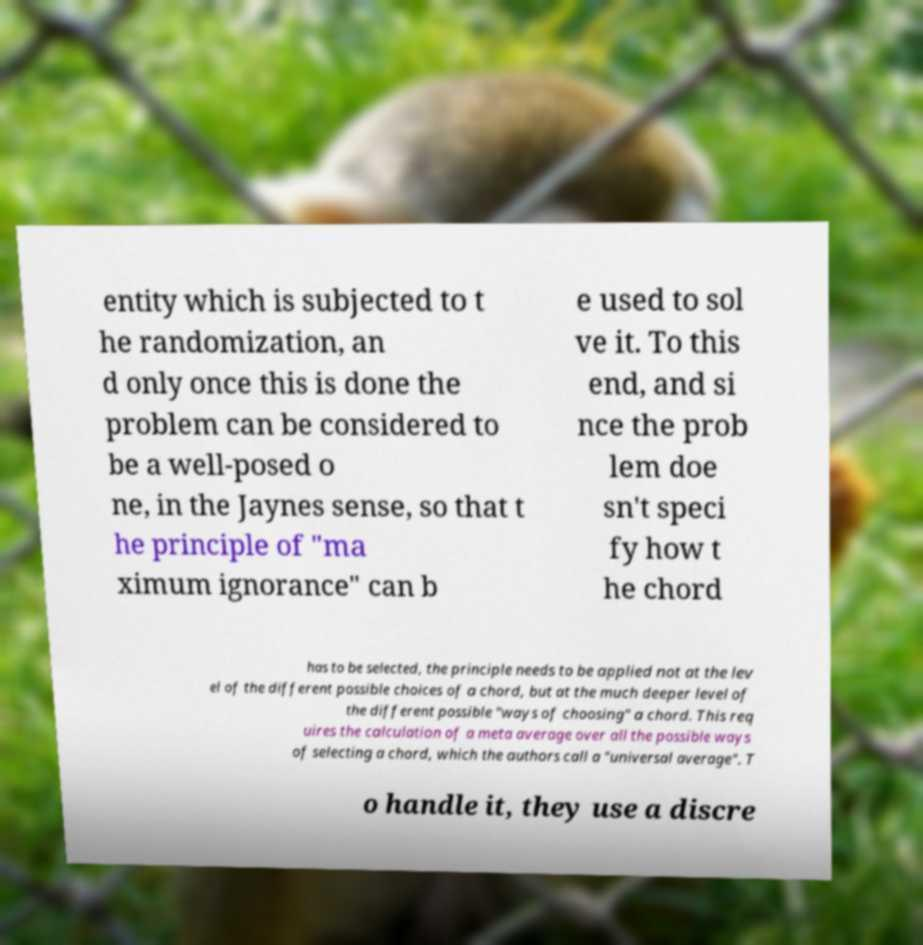Please identify and transcribe the text found in this image. entity which is subjected to t he randomization, an d only once this is done the problem can be considered to be a well-posed o ne, in the Jaynes sense, so that t he principle of "ma ximum ignorance" can b e used to sol ve it. To this end, and si nce the prob lem doe sn't speci fy how t he chord has to be selected, the principle needs to be applied not at the lev el of the different possible choices of a chord, but at the much deeper level of the different possible "ways of choosing" a chord. This req uires the calculation of a meta average over all the possible ways of selecting a chord, which the authors call a "universal average". T o handle it, they use a discre 